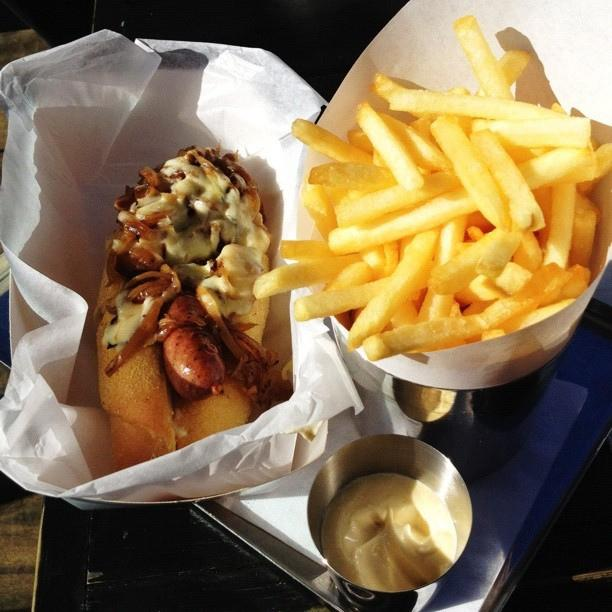What place sells these items? Please explain your reasoning. sonic. Sonic sells hot dogs and fries. 